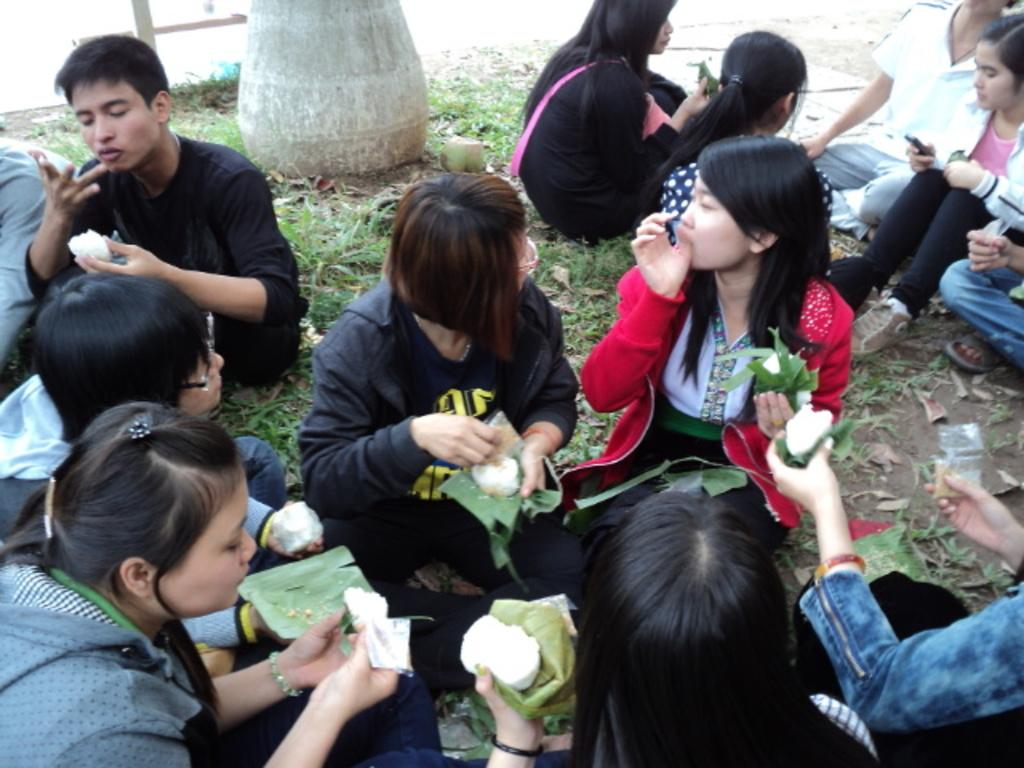How many people are in the image? There is a group of people in the image, but the exact number is not specified. What are the people doing in the image? The people are sitting on the ground and eating something. What type of surface are the people sitting on? The people are sitting on the ground. What can be seen around the people? There is grass around the people. What type of map is the group of people using to find their way in the image? There is no map present in the image; the people are sitting on the ground and eating something. What reward is the group of people receiving for their actions in the image? There is no reward mentioned or depicted in the image; the people are simply sitting and eating. 